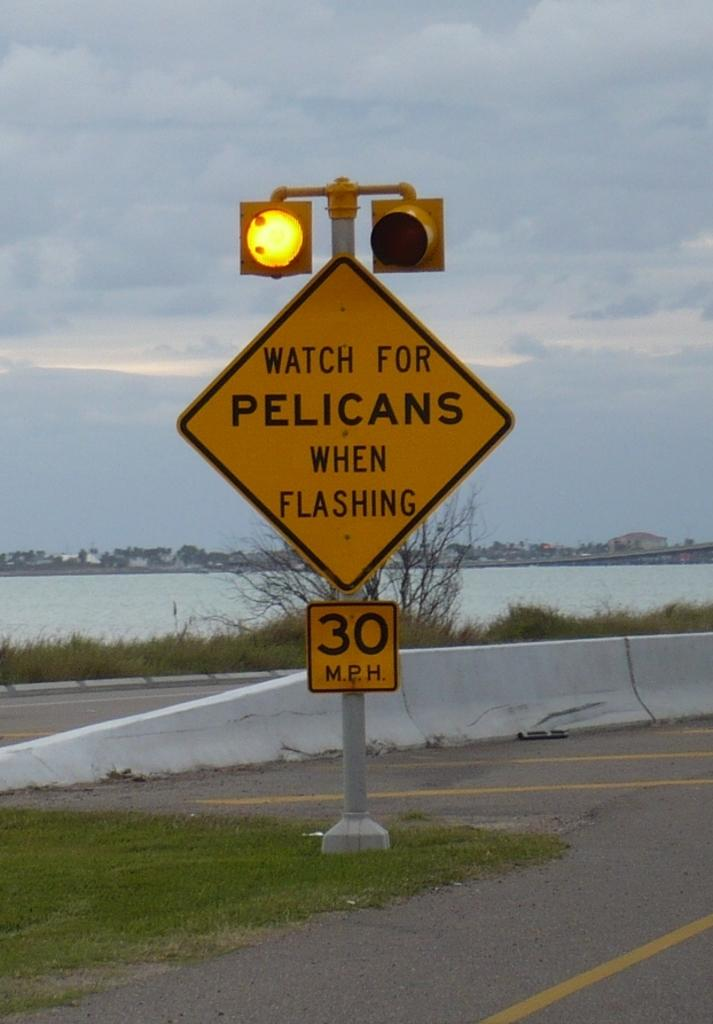<image>
Summarize the visual content of the image. A caution sign with lights saying to look for pelicans when the light is flashing. 